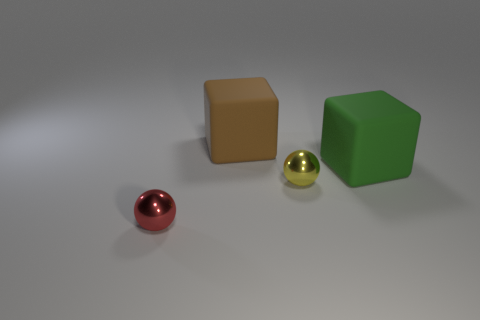Add 1 brown cubes. How many objects exist? 5 Add 2 green rubber things. How many green rubber things are left? 3 Add 3 tiny purple balls. How many tiny purple balls exist? 3 Subtract 0 purple spheres. How many objects are left? 4 Subtract all small green blocks. Subtract all shiny spheres. How many objects are left? 2 